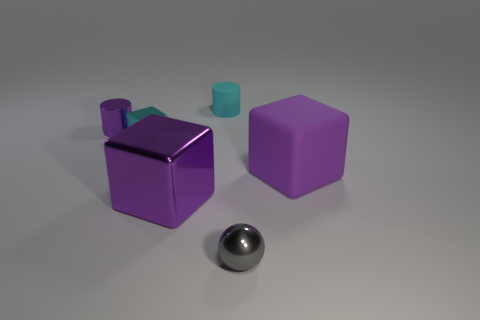Subtract all brown cubes. Subtract all blue cylinders. How many cubes are left? 3 Add 4 purple metallic cylinders. How many objects exist? 10 Subtract all cylinders. How many objects are left? 4 Subtract 0 blue balls. How many objects are left? 6 Subtract all tiny shiny things. Subtract all green metal cubes. How many objects are left? 3 Add 2 big purple shiny objects. How many big purple shiny objects are left? 3 Add 3 small cyan shiny things. How many small cyan shiny things exist? 4 